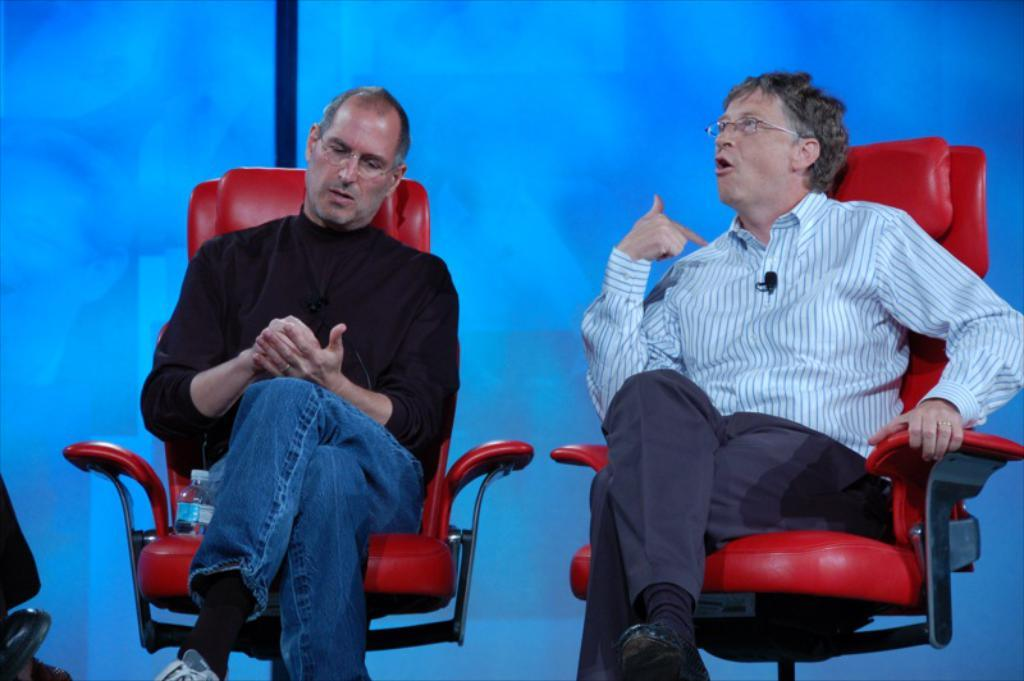How many people are in the image? There are two persons in the image. What are the persons sitting on? The persons are sitting on a red chair. What object is beside one of the persons? There is a bottle beside one of the persons. What is one of the persons doing in the image? One of the persons is speaking, as indicated by lip and hand movements. What taste can be detected from the red chair in the image? The red chair does not have a taste, as it is an inanimate object. 